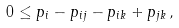<formula> <loc_0><loc_0><loc_500><loc_500>0 \leq p _ { i } - p _ { i j } - p _ { i k } + p _ { j k } \, ,</formula> 